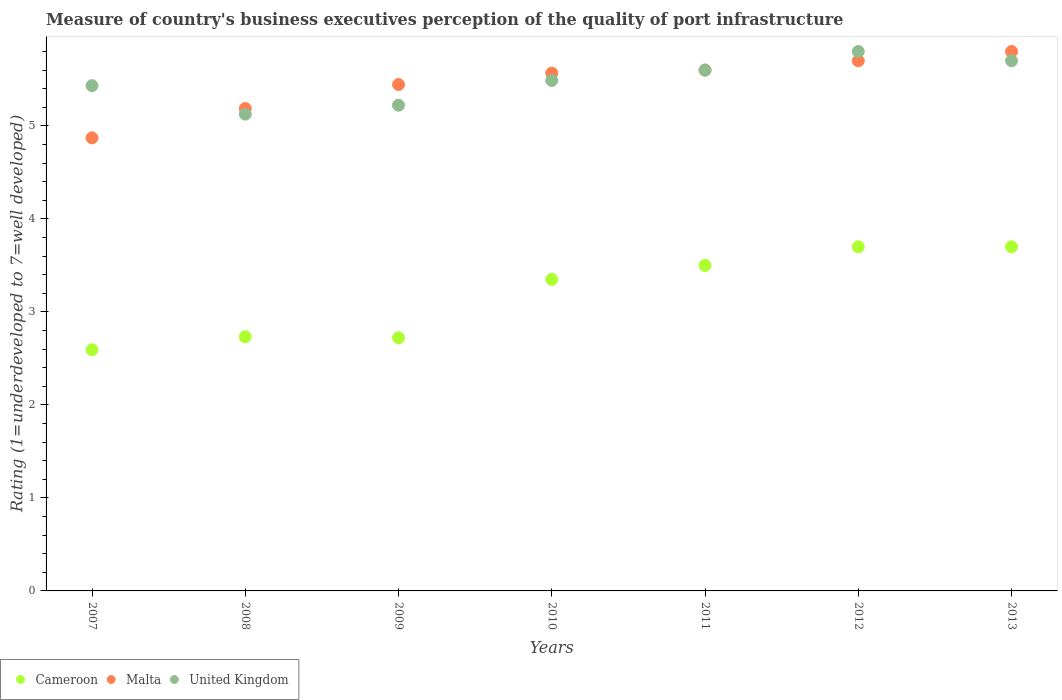Is the number of dotlines equal to the number of legend labels?
Your answer should be very brief. Yes. What is the ratings of the quality of port infrastructure in United Kingdom in 2010?
Offer a very short reply. 5.49. Across all years, what is the maximum ratings of the quality of port infrastructure in Malta?
Offer a terse response. 5.8. Across all years, what is the minimum ratings of the quality of port infrastructure in Cameroon?
Provide a short and direct response. 2.59. In which year was the ratings of the quality of port infrastructure in Malta maximum?
Your response must be concise. 2013. In which year was the ratings of the quality of port infrastructure in United Kingdom minimum?
Give a very brief answer. 2008. What is the total ratings of the quality of port infrastructure in United Kingdom in the graph?
Ensure brevity in your answer.  38.37. What is the difference between the ratings of the quality of port infrastructure in Malta in 2008 and that in 2009?
Provide a succinct answer. -0.26. What is the difference between the ratings of the quality of port infrastructure in Cameroon in 2007 and the ratings of the quality of port infrastructure in United Kingdom in 2012?
Your response must be concise. -3.21. What is the average ratings of the quality of port infrastructure in Malta per year?
Keep it short and to the point. 5.45. In the year 2009, what is the difference between the ratings of the quality of port infrastructure in Malta and ratings of the quality of port infrastructure in United Kingdom?
Make the answer very short. 0.22. What is the ratio of the ratings of the quality of port infrastructure in Malta in 2012 to that in 2013?
Make the answer very short. 0.98. Is the difference between the ratings of the quality of port infrastructure in Malta in 2007 and 2012 greater than the difference between the ratings of the quality of port infrastructure in United Kingdom in 2007 and 2012?
Make the answer very short. No. What is the difference between the highest and the second highest ratings of the quality of port infrastructure in Cameroon?
Offer a very short reply. 0. What is the difference between the highest and the lowest ratings of the quality of port infrastructure in United Kingdom?
Your response must be concise. 0.67. Is the sum of the ratings of the quality of port infrastructure in Cameroon in 2009 and 2010 greater than the maximum ratings of the quality of port infrastructure in United Kingdom across all years?
Offer a very short reply. Yes. Is it the case that in every year, the sum of the ratings of the quality of port infrastructure in Malta and ratings of the quality of port infrastructure in United Kingdom  is greater than the ratings of the quality of port infrastructure in Cameroon?
Your answer should be very brief. Yes. Is the ratings of the quality of port infrastructure in Cameroon strictly less than the ratings of the quality of port infrastructure in Malta over the years?
Make the answer very short. Yes. How many dotlines are there?
Make the answer very short. 3. How many years are there in the graph?
Make the answer very short. 7. What is the difference between two consecutive major ticks on the Y-axis?
Offer a very short reply. 1. Are the values on the major ticks of Y-axis written in scientific E-notation?
Offer a terse response. No. Does the graph contain grids?
Offer a very short reply. No. How many legend labels are there?
Keep it short and to the point. 3. How are the legend labels stacked?
Provide a succinct answer. Horizontal. What is the title of the graph?
Provide a short and direct response. Measure of country's business executives perception of the quality of port infrastructure. Does "Bosnia and Herzegovina" appear as one of the legend labels in the graph?
Offer a very short reply. No. What is the label or title of the X-axis?
Your answer should be compact. Years. What is the label or title of the Y-axis?
Keep it short and to the point. Rating (1=underdeveloped to 7=well developed). What is the Rating (1=underdeveloped to 7=well developed) of Cameroon in 2007?
Offer a terse response. 2.59. What is the Rating (1=underdeveloped to 7=well developed) in Malta in 2007?
Ensure brevity in your answer.  4.87. What is the Rating (1=underdeveloped to 7=well developed) in United Kingdom in 2007?
Keep it short and to the point. 5.43. What is the Rating (1=underdeveloped to 7=well developed) in Cameroon in 2008?
Provide a succinct answer. 2.73. What is the Rating (1=underdeveloped to 7=well developed) in Malta in 2008?
Provide a short and direct response. 5.19. What is the Rating (1=underdeveloped to 7=well developed) of United Kingdom in 2008?
Keep it short and to the point. 5.13. What is the Rating (1=underdeveloped to 7=well developed) in Cameroon in 2009?
Keep it short and to the point. 2.72. What is the Rating (1=underdeveloped to 7=well developed) of Malta in 2009?
Offer a terse response. 5.44. What is the Rating (1=underdeveloped to 7=well developed) of United Kingdom in 2009?
Provide a succinct answer. 5.22. What is the Rating (1=underdeveloped to 7=well developed) of Cameroon in 2010?
Offer a terse response. 3.35. What is the Rating (1=underdeveloped to 7=well developed) of Malta in 2010?
Make the answer very short. 5.57. What is the Rating (1=underdeveloped to 7=well developed) of United Kingdom in 2010?
Offer a terse response. 5.49. What is the Rating (1=underdeveloped to 7=well developed) of Malta in 2011?
Your answer should be very brief. 5.6. What is the Rating (1=underdeveloped to 7=well developed) of United Kingdom in 2011?
Offer a very short reply. 5.6. What is the Rating (1=underdeveloped to 7=well developed) in Malta in 2012?
Your response must be concise. 5.7. What is the Rating (1=underdeveloped to 7=well developed) in United Kingdom in 2012?
Make the answer very short. 5.8. Across all years, what is the maximum Rating (1=underdeveloped to 7=well developed) of United Kingdom?
Your response must be concise. 5.8. Across all years, what is the minimum Rating (1=underdeveloped to 7=well developed) in Cameroon?
Provide a succinct answer. 2.59. Across all years, what is the minimum Rating (1=underdeveloped to 7=well developed) of Malta?
Make the answer very short. 4.87. Across all years, what is the minimum Rating (1=underdeveloped to 7=well developed) in United Kingdom?
Provide a short and direct response. 5.13. What is the total Rating (1=underdeveloped to 7=well developed) of Cameroon in the graph?
Provide a succinct answer. 22.3. What is the total Rating (1=underdeveloped to 7=well developed) in Malta in the graph?
Your answer should be compact. 38.17. What is the total Rating (1=underdeveloped to 7=well developed) in United Kingdom in the graph?
Offer a terse response. 38.37. What is the difference between the Rating (1=underdeveloped to 7=well developed) of Cameroon in 2007 and that in 2008?
Your answer should be compact. -0.14. What is the difference between the Rating (1=underdeveloped to 7=well developed) of Malta in 2007 and that in 2008?
Provide a short and direct response. -0.32. What is the difference between the Rating (1=underdeveloped to 7=well developed) of United Kingdom in 2007 and that in 2008?
Give a very brief answer. 0.31. What is the difference between the Rating (1=underdeveloped to 7=well developed) in Cameroon in 2007 and that in 2009?
Your answer should be compact. -0.13. What is the difference between the Rating (1=underdeveloped to 7=well developed) in Malta in 2007 and that in 2009?
Offer a terse response. -0.57. What is the difference between the Rating (1=underdeveloped to 7=well developed) in United Kingdom in 2007 and that in 2009?
Provide a succinct answer. 0.21. What is the difference between the Rating (1=underdeveloped to 7=well developed) in Cameroon in 2007 and that in 2010?
Offer a very short reply. -0.76. What is the difference between the Rating (1=underdeveloped to 7=well developed) in Malta in 2007 and that in 2010?
Ensure brevity in your answer.  -0.7. What is the difference between the Rating (1=underdeveloped to 7=well developed) of United Kingdom in 2007 and that in 2010?
Make the answer very short. -0.06. What is the difference between the Rating (1=underdeveloped to 7=well developed) in Cameroon in 2007 and that in 2011?
Provide a short and direct response. -0.91. What is the difference between the Rating (1=underdeveloped to 7=well developed) in Malta in 2007 and that in 2011?
Provide a succinct answer. -0.73. What is the difference between the Rating (1=underdeveloped to 7=well developed) in United Kingdom in 2007 and that in 2011?
Offer a terse response. -0.17. What is the difference between the Rating (1=underdeveloped to 7=well developed) in Cameroon in 2007 and that in 2012?
Your answer should be very brief. -1.11. What is the difference between the Rating (1=underdeveloped to 7=well developed) in Malta in 2007 and that in 2012?
Offer a terse response. -0.83. What is the difference between the Rating (1=underdeveloped to 7=well developed) in United Kingdom in 2007 and that in 2012?
Your answer should be compact. -0.37. What is the difference between the Rating (1=underdeveloped to 7=well developed) in Cameroon in 2007 and that in 2013?
Your answer should be compact. -1.11. What is the difference between the Rating (1=underdeveloped to 7=well developed) in Malta in 2007 and that in 2013?
Keep it short and to the point. -0.93. What is the difference between the Rating (1=underdeveloped to 7=well developed) in United Kingdom in 2007 and that in 2013?
Keep it short and to the point. -0.27. What is the difference between the Rating (1=underdeveloped to 7=well developed) in Cameroon in 2008 and that in 2009?
Make the answer very short. 0.01. What is the difference between the Rating (1=underdeveloped to 7=well developed) of Malta in 2008 and that in 2009?
Offer a terse response. -0.26. What is the difference between the Rating (1=underdeveloped to 7=well developed) in United Kingdom in 2008 and that in 2009?
Keep it short and to the point. -0.1. What is the difference between the Rating (1=underdeveloped to 7=well developed) of Cameroon in 2008 and that in 2010?
Offer a very short reply. -0.62. What is the difference between the Rating (1=underdeveloped to 7=well developed) of Malta in 2008 and that in 2010?
Ensure brevity in your answer.  -0.38. What is the difference between the Rating (1=underdeveloped to 7=well developed) in United Kingdom in 2008 and that in 2010?
Your response must be concise. -0.36. What is the difference between the Rating (1=underdeveloped to 7=well developed) of Cameroon in 2008 and that in 2011?
Provide a short and direct response. -0.77. What is the difference between the Rating (1=underdeveloped to 7=well developed) in Malta in 2008 and that in 2011?
Your response must be concise. -0.41. What is the difference between the Rating (1=underdeveloped to 7=well developed) in United Kingdom in 2008 and that in 2011?
Offer a very short reply. -0.47. What is the difference between the Rating (1=underdeveloped to 7=well developed) of Cameroon in 2008 and that in 2012?
Give a very brief answer. -0.97. What is the difference between the Rating (1=underdeveloped to 7=well developed) of Malta in 2008 and that in 2012?
Offer a very short reply. -0.51. What is the difference between the Rating (1=underdeveloped to 7=well developed) in United Kingdom in 2008 and that in 2012?
Offer a very short reply. -0.67. What is the difference between the Rating (1=underdeveloped to 7=well developed) in Cameroon in 2008 and that in 2013?
Offer a terse response. -0.97. What is the difference between the Rating (1=underdeveloped to 7=well developed) in Malta in 2008 and that in 2013?
Offer a very short reply. -0.61. What is the difference between the Rating (1=underdeveloped to 7=well developed) of United Kingdom in 2008 and that in 2013?
Your answer should be compact. -0.57. What is the difference between the Rating (1=underdeveloped to 7=well developed) of Cameroon in 2009 and that in 2010?
Your answer should be compact. -0.63. What is the difference between the Rating (1=underdeveloped to 7=well developed) of Malta in 2009 and that in 2010?
Provide a succinct answer. -0.12. What is the difference between the Rating (1=underdeveloped to 7=well developed) in United Kingdom in 2009 and that in 2010?
Offer a terse response. -0.27. What is the difference between the Rating (1=underdeveloped to 7=well developed) in Cameroon in 2009 and that in 2011?
Your response must be concise. -0.78. What is the difference between the Rating (1=underdeveloped to 7=well developed) of Malta in 2009 and that in 2011?
Give a very brief answer. -0.15. What is the difference between the Rating (1=underdeveloped to 7=well developed) of United Kingdom in 2009 and that in 2011?
Your answer should be compact. -0.38. What is the difference between the Rating (1=underdeveloped to 7=well developed) in Cameroon in 2009 and that in 2012?
Offer a very short reply. -0.98. What is the difference between the Rating (1=underdeveloped to 7=well developed) of Malta in 2009 and that in 2012?
Offer a terse response. -0.26. What is the difference between the Rating (1=underdeveloped to 7=well developed) in United Kingdom in 2009 and that in 2012?
Provide a short and direct response. -0.58. What is the difference between the Rating (1=underdeveloped to 7=well developed) of Cameroon in 2009 and that in 2013?
Your answer should be compact. -0.98. What is the difference between the Rating (1=underdeveloped to 7=well developed) in Malta in 2009 and that in 2013?
Make the answer very short. -0.35. What is the difference between the Rating (1=underdeveloped to 7=well developed) of United Kingdom in 2009 and that in 2013?
Offer a very short reply. -0.48. What is the difference between the Rating (1=underdeveloped to 7=well developed) of Cameroon in 2010 and that in 2011?
Offer a very short reply. -0.15. What is the difference between the Rating (1=underdeveloped to 7=well developed) in Malta in 2010 and that in 2011?
Provide a short and direct response. -0.03. What is the difference between the Rating (1=underdeveloped to 7=well developed) in United Kingdom in 2010 and that in 2011?
Your answer should be compact. -0.11. What is the difference between the Rating (1=underdeveloped to 7=well developed) in Cameroon in 2010 and that in 2012?
Your answer should be compact. -0.35. What is the difference between the Rating (1=underdeveloped to 7=well developed) of Malta in 2010 and that in 2012?
Keep it short and to the point. -0.13. What is the difference between the Rating (1=underdeveloped to 7=well developed) in United Kingdom in 2010 and that in 2012?
Make the answer very short. -0.31. What is the difference between the Rating (1=underdeveloped to 7=well developed) of Cameroon in 2010 and that in 2013?
Provide a short and direct response. -0.35. What is the difference between the Rating (1=underdeveloped to 7=well developed) in Malta in 2010 and that in 2013?
Offer a very short reply. -0.23. What is the difference between the Rating (1=underdeveloped to 7=well developed) of United Kingdom in 2010 and that in 2013?
Keep it short and to the point. -0.21. What is the difference between the Rating (1=underdeveloped to 7=well developed) of Cameroon in 2011 and that in 2013?
Offer a terse response. -0.2. What is the difference between the Rating (1=underdeveloped to 7=well developed) in Malta in 2011 and that in 2013?
Your answer should be very brief. -0.2. What is the difference between the Rating (1=underdeveloped to 7=well developed) of United Kingdom in 2011 and that in 2013?
Provide a succinct answer. -0.1. What is the difference between the Rating (1=underdeveloped to 7=well developed) of Cameroon in 2012 and that in 2013?
Your response must be concise. 0. What is the difference between the Rating (1=underdeveloped to 7=well developed) in Malta in 2012 and that in 2013?
Provide a succinct answer. -0.1. What is the difference between the Rating (1=underdeveloped to 7=well developed) in Cameroon in 2007 and the Rating (1=underdeveloped to 7=well developed) in Malta in 2008?
Your response must be concise. -2.59. What is the difference between the Rating (1=underdeveloped to 7=well developed) in Cameroon in 2007 and the Rating (1=underdeveloped to 7=well developed) in United Kingdom in 2008?
Provide a short and direct response. -2.53. What is the difference between the Rating (1=underdeveloped to 7=well developed) in Malta in 2007 and the Rating (1=underdeveloped to 7=well developed) in United Kingdom in 2008?
Your answer should be compact. -0.25. What is the difference between the Rating (1=underdeveloped to 7=well developed) in Cameroon in 2007 and the Rating (1=underdeveloped to 7=well developed) in Malta in 2009?
Make the answer very short. -2.85. What is the difference between the Rating (1=underdeveloped to 7=well developed) of Cameroon in 2007 and the Rating (1=underdeveloped to 7=well developed) of United Kingdom in 2009?
Your response must be concise. -2.63. What is the difference between the Rating (1=underdeveloped to 7=well developed) in Malta in 2007 and the Rating (1=underdeveloped to 7=well developed) in United Kingdom in 2009?
Offer a very short reply. -0.35. What is the difference between the Rating (1=underdeveloped to 7=well developed) in Cameroon in 2007 and the Rating (1=underdeveloped to 7=well developed) in Malta in 2010?
Make the answer very short. -2.97. What is the difference between the Rating (1=underdeveloped to 7=well developed) in Cameroon in 2007 and the Rating (1=underdeveloped to 7=well developed) in United Kingdom in 2010?
Offer a terse response. -2.9. What is the difference between the Rating (1=underdeveloped to 7=well developed) of Malta in 2007 and the Rating (1=underdeveloped to 7=well developed) of United Kingdom in 2010?
Your answer should be compact. -0.62. What is the difference between the Rating (1=underdeveloped to 7=well developed) in Cameroon in 2007 and the Rating (1=underdeveloped to 7=well developed) in Malta in 2011?
Ensure brevity in your answer.  -3.01. What is the difference between the Rating (1=underdeveloped to 7=well developed) in Cameroon in 2007 and the Rating (1=underdeveloped to 7=well developed) in United Kingdom in 2011?
Give a very brief answer. -3.01. What is the difference between the Rating (1=underdeveloped to 7=well developed) in Malta in 2007 and the Rating (1=underdeveloped to 7=well developed) in United Kingdom in 2011?
Your answer should be very brief. -0.73. What is the difference between the Rating (1=underdeveloped to 7=well developed) in Cameroon in 2007 and the Rating (1=underdeveloped to 7=well developed) in Malta in 2012?
Keep it short and to the point. -3.11. What is the difference between the Rating (1=underdeveloped to 7=well developed) of Cameroon in 2007 and the Rating (1=underdeveloped to 7=well developed) of United Kingdom in 2012?
Your answer should be very brief. -3.21. What is the difference between the Rating (1=underdeveloped to 7=well developed) of Malta in 2007 and the Rating (1=underdeveloped to 7=well developed) of United Kingdom in 2012?
Provide a succinct answer. -0.93. What is the difference between the Rating (1=underdeveloped to 7=well developed) in Cameroon in 2007 and the Rating (1=underdeveloped to 7=well developed) in Malta in 2013?
Offer a very short reply. -3.21. What is the difference between the Rating (1=underdeveloped to 7=well developed) in Cameroon in 2007 and the Rating (1=underdeveloped to 7=well developed) in United Kingdom in 2013?
Keep it short and to the point. -3.11. What is the difference between the Rating (1=underdeveloped to 7=well developed) of Malta in 2007 and the Rating (1=underdeveloped to 7=well developed) of United Kingdom in 2013?
Your answer should be very brief. -0.83. What is the difference between the Rating (1=underdeveloped to 7=well developed) in Cameroon in 2008 and the Rating (1=underdeveloped to 7=well developed) in Malta in 2009?
Offer a very short reply. -2.71. What is the difference between the Rating (1=underdeveloped to 7=well developed) of Cameroon in 2008 and the Rating (1=underdeveloped to 7=well developed) of United Kingdom in 2009?
Your answer should be compact. -2.49. What is the difference between the Rating (1=underdeveloped to 7=well developed) in Malta in 2008 and the Rating (1=underdeveloped to 7=well developed) in United Kingdom in 2009?
Ensure brevity in your answer.  -0.04. What is the difference between the Rating (1=underdeveloped to 7=well developed) in Cameroon in 2008 and the Rating (1=underdeveloped to 7=well developed) in Malta in 2010?
Give a very brief answer. -2.84. What is the difference between the Rating (1=underdeveloped to 7=well developed) of Cameroon in 2008 and the Rating (1=underdeveloped to 7=well developed) of United Kingdom in 2010?
Your answer should be compact. -2.76. What is the difference between the Rating (1=underdeveloped to 7=well developed) in Malta in 2008 and the Rating (1=underdeveloped to 7=well developed) in United Kingdom in 2010?
Give a very brief answer. -0.3. What is the difference between the Rating (1=underdeveloped to 7=well developed) of Cameroon in 2008 and the Rating (1=underdeveloped to 7=well developed) of Malta in 2011?
Your response must be concise. -2.87. What is the difference between the Rating (1=underdeveloped to 7=well developed) in Cameroon in 2008 and the Rating (1=underdeveloped to 7=well developed) in United Kingdom in 2011?
Your response must be concise. -2.87. What is the difference between the Rating (1=underdeveloped to 7=well developed) in Malta in 2008 and the Rating (1=underdeveloped to 7=well developed) in United Kingdom in 2011?
Your answer should be compact. -0.41. What is the difference between the Rating (1=underdeveloped to 7=well developed) in Cameroon in 2008 and the Rating (1=underdeveloped to 7=well developed) in Malta in 2012?
Keep it short and to the point. -2.97. What is the difference between the Rating (1=underdeveloped to 7=well developed) of Cameroon in 2008 and the Rating (1=underdeveloped to 7=well developed) of United Kingdom in 2012?
Ensure brevity in your answer.  -3.07. What is the difference between the Rating (1=underdeveloped to 7=well developed) in Malta in 2008 and the Rating (1=underdeveloped to 7=well developed) in United Kingdom in 2012?
Ensure brevity in your answer.  -0.61. What is the difference between the Rating (1=underdeveloped to 7=well developed) of Cameroon in 2008 and the Rating (1=underdeveloped to 7=well developed) of Malta in 2013?
Ensure brevity in your answer.  -3.07. What is the difference between the Rating (1=underdeveloped to 7=well developed) in Cameroon in 2008 and the Rating (1=underdeveloped to 7=well developed) in United Kingdom in 2013?
Give a very brief answer. -2.97. What is the difference between the Rating (1=underdeveloped to 7=well developed) in Malta in 2008 and the Rating (1=underdeveloped to 7=well developed) in United Kingdom in 2013?
Keep it short and to the point. -0.51. What is the difference between the Rating (1=underdeveloped to 7=well developed) of Cameroon in 2009 and the Rating (1=underdeveloped to 7=well developed) of Malta in 2010?
Keep it short and to the point. -2.85. What is the difference between the Rating (1=underdeveloped to 7=well developed) in Cameroon in 2009 and the Rating (1=underdeveloped to 7=well developed) in United Kingdom in 2010?
Give a very brief answer. -2.77. What is the difference between the Rating (1=underdeveloped to 7=well developed) in Malta in 2009 and the Rating (1=underdeveloped to 7=well developed) in United Kingdom in 2010?
Offer a very short reply. -0.04. What is the difference between the Rating (1=underdeveloped to 7=well developed) of Cameroon in 2009 and the Rating (1=underdeveloped to 7=well developed) of Malta in 2011?
Your answer should be compact. -2.88. What is the difference between the Rating (1=underdeveloped to 7=well developed) in Cameroon in 2009 and the Rating (1=underdeveloped to 7=well developed) in United Kingdom in 2011?
Offer a very short reply. -2.88. What is the difference between the Rating (1=underdeveloped to 7=well developed) of Malta in 2009 and the Rating (1=underdeveloped to 7=well developed) of United Kingdom in 2011?
Provide a short and direct response. -0.15. What is the difference between the Rating (1=underdeveloped to 7=well developed) in Cameroon in 2009 and the Rating (1=underdeveloped to 7=well developed) in Malta in 2012?
Your response must be concise. -2.98. What is the difference between the Rating (1=underdeveloped to 7=well developed) of Cameroon in 2009 and the Rating (1=underdeveloped to 7=well developed) of United Kingdom in 2012?
Keep it short and to the point. -3.08. What is the difference between the Rating (1=underdeveloped to 7=well developed) of Malta in 2009 and the Rating (1=underdeveloped to 7=well developed) of United Kingdom in 2012?
Give a very brief answer. -0.35. What is the difference between the Rating (1=underdeveloped to 7=well developed) in Cameroon in 2009 and the Rating (1=underdeveloped to 7=well developed) in Malta in 2013?
Your answer should be very brief. -3.08. What is the difference between the Rating (1=underdeveloped to 7=well developed) of Cameroon in 2009 and the Rating (1=underdeveloped to 7=well developed) of United Kingdom in 2013?
Make the answer very short. -2.98. What is the difference between the Rating (1=underdeveloped to 7=well developed) in Malta in 2009 and the Rating (1=underdeveloped to 7=well developed) in United Kingdom in 2013?
Keep it short and to the point. -0.26. What is the difference between the Rating (1=underdeveloped to 7=well developed) in Cameroon in 2010 and the Rating (1=underdeveloped to 7=well developed) in Malta in 2011?
Ensure brevity in your answer.  -2.25. What is the difference between the Rating (1=underdeveloped to 7=well developed) of Cameroon in 2010 and the Rating (1=underdeveloped to 7=well developed) of United Kingdom in 2011?
Keep it short and to the point. -2.25. What is the difference between the Rating (1=underdeveloped to 7=well developed) of Malta in 2010 and the Rating (1=underdeveloped to 7=well developed) of United Kingdom in 2011?
Provide a short and direct response. -0.03. What is the difference between the Rating (1=underdeveloped to 7=well developed) in Cameroon in 2010 and the Rating (1=underdeveloped to 7=well developed) in Malta in 2012?
Make the answer very short. -2.35. What is the difference between the Rating (1=underdeveloped to 7=well developed) of Cameroon in 2010 and the Rating (1=underdeveloped to 7=well developed) of United Kingdom in 2012?
Your response must be concise. -2.45. What is the difference between the Rating (1=underdeveloped to 7=well developed) of Malta in 2010 and the Rating (1=underdeveloped to 7=well developed) of United Kingdom in 2012?
Your answer should be compact. -0.23. What is the difference between the Rating (1=underdeveloped to 7=well developed) of Cameroon in 2010 and the Rating (1=underdeveloped to 7=well developed) of Malta in 2013?
Your answer should be compact. -2.45. What is the difference between the Rating (1=underdeveloped to 7=well developed) of Cameroon in 2010 and the Rating (1=underdeveloped to 7=well developed) of United Kingdom in 2013?
Ensure brevity in your answer.  -2.35. What is the difference between the Rating (1=underdeveloped to 7=well developed) of Malta in 2010 and the Rating (1=underdeveloped to 7=well developed) of United Kingdom in 2013?
Provide a succinct answer. -0.13. What is the difference between the Rating (1=underdeveloped to 7=well developed) of Cameroon in 2011 and the Rating (1=underdeveloped to 7=well developed) of United Kingdom in 2012?
Provide a short and direct response. -2.3. What is the difference between the Rating (1=underdeveloped to 7=well developed) of Cameroon in 2011 and the Rating (1=underdeveloped to 7=well developed) of Malta in 2013?
Make the answer very short. -2.3. What is the difference between the Rating (1=underdeveloped to 7=well developed) of Cameroon in 2011 and the Rating (1=underdeveloped to 7=well developed) of United Kingdom in 2013?
Make the answer very short. -2.2. What is the difference between the Rating (1=underdeveloped to 7=well developed) of Malta in 2011 and the Rating (1=underdeveloped to 7=well developed) of United Kingdom in 2013?
Provide a succinct answer. -0.1. What is the difference between the Rating (1=underdeveloped to 7=well developed) of Cameroon in 2012 and the Rating (1=underdeveloped to 7=well developed) of Malta in 2013?
Offer a very short reply. -2.1. What is the difference between the Rating (1=underdeveloped to 7=well developed) in Malta in 2012 and the Rating (1=underdeveloped to 7=well developed) in United Kingdom in 2013?
Provide a succinct answer. 0. What is the average Rating (1=underdeveloped to 7=well developed) of Cameroon per year?
Your answer should be compact. 3.19. What is the average Rating (1=underdeveloped to 7=well developed) in Malta per year?
Offer a very short reply. 5.45. What is the average Rating (1=underdeveloped to 7=well developed) of United Kingdom per year?
Your response must be concise. 5.48. In the year 2007, what is the difference between the Rating (1=underdeveloped to 7=well developed) in Cameroon and Rating (1=underdeveloped to 7=well developed) in Malta?
Your answer should be compact. -2.28. In the year 2007, what is the difference between the Rating (1=underdeveloped to 7=well developed) of Cameroon and Rating (1=underdeveloped to 7=well developed) of United Kingdom?
Offer a terse response. -2.84. In the year 2007, what is the difference between the Rating (1=underdeveloped to 7=well developed) in Malta and Rating (1=underdeveloped to 7=well developed) in United Kingdom?
Offer a terse response. -0.56. In the year 2008, what is the difference between the Rating (1=underdeveloped to 7=well developed) in Cameroon and Rating (1=underdeveloped to 7=well developed) in Malta?
Your answer should be compact. -2.45. In the year 2008, what is the difference between the Rating (1=underdeveloped to 7=well developed) in Cameroon and Rating (1=underdeveloped to 7=well developed) in United Kingdom?
Give a very brief answer. -2.39. In the year 2008, what is the difference between the Rating (1=underdeveloped to 7=well developed) in Malta and Rating (1=underdeveloped to 7=well developed) in United Kingdom?
Ensure brevity in your answer.  0.06. In the year 2009, what is the difference between the Rating (1=underdeveloped to 7=well developed) of Cameroon and Rating (1=underdeveloped to 7=well developed) of Malta?
Provide a short and direct response. -2.72. In the year 2009, what is the difference between the Rating (1=underdeveloped to 7=well developed) of Cameroon and Rating (1=underdeveloped to 7=well developed) of United Kingdom?
Your answer should be very brief. -2.5. In the year 2009, what is the difference between the Rating (1=underdeveloped to 7=well developed) of Malta and Rating (1=underdeveloped to 7=well developed) of United Kingdom?
Provide a succinct answer. 0.22. In the year 2010, what is the difference between the Rating (1=underdeveloped to 7=well developed) in Cameroon and Rating (1=underdeveloped to 7=well developed) in Malta?
Your response must be concise. -2.22. In the year 2010, what is the difference between the Rating (1=underdeveloped to 7=well developed) in Cameroon and Rating (1=underdeveloped to 7=well developed) in United Kingdom?
Keep it short and to the point. -2.14. In the year 2010, what is the difference between the Rating (1=underdeveloped to 7=well developed) in Malta and Rating (1=underdeveloped to 7=well developed) in United Kingdom?
Offer a terse response. 0.08. In the year 2011, what is the difference between the Rating (1=underdeveloped to 7=well developed) in Cameroon and Rating (1=underdeveloped to 7=well developed) in Malta?
Ensure brevity in your answer.  -2.1. In the year 2012, what is the difference between the Rating (1=underdeveloped to 7=well developed) of Cameroon and Rating (1=underdeveloped to 7=well developed) of Malta?
Your answer should be very brief. -2. In the year 2012, what is the difference between the Rating (1=underdeveloped to 7=well developed) of Malta and Rating (1=underdeveloped to 7=well developed) of United Kingdom?
Your response must be concise. -0.1. In the year 2013, what is the difference between the Rating (1=underdeveloped to 7=well developed) of Malta and Rating (1=underdeveloped to 7=well developed) of United Kingdom?
Offer a terse response. 0.1. What is the ratio of the Rating (1=underdeveloped to 7=well developed) in Cameroon in 2007 to that in 2008?
Your answer should be very brief. 0.95. What is the ratio of the Rating (1=underdeveloped to 7=well developed) of Malta in 2007 to that in 2008?
Offer a very short reply. 0.94. What is the ratio of the Rating (1=underdeveloped to 7=well developed) of United Kingdom in 2007 to that in 2008?
Give a very brief answer. 1.06. What is the ratio of the Rating (1=underdeveloped to 7=well developed) of Cameroon in 2007 to that in 2009?
Ensure brevity in your answer.  0.95. What is the ratio of the Rating (1=underdeveloped to 7=well developed) of Malta in 2007 to that in 2009?
Keep it short and to the point. 0.89. What is the ratio of the Rating (1=underdeveloped to 7=well developed) in United Kingdom in 2007 to that in 2009?
Give a very brief answer. 1.04. What is the ratio of the Rating (1=underdeveloped to 7=well developed) of Cameroon in 2007 to that in 2010?
Keep it short and to the point. 0.77. What is the ratio of the Rating (1=underdeveloped to 7=well developed) of Malta in 2007 to that in 2010?
Provide a short and direct response. 0.88. What is the ratio of the Rating (1=underdeveloped to 7=well developed) of Cameroon in 2007 to that in 2011?
Offer a terse response. 0.74. What is the ratio of the Rating (1=underdeveloped to 7=well developed) in Malta in 2007 to that in 2011?
Keep it short and to the point. 0.87. What is the ratio of the Rating (1=underdeveloped to 7=well developed) in United Kingdom in 2007 to that in 2011?
Ensure brevity in your answer.  0.97. What is the ratio of the Rating (1=underdeveloped to 7=well developed) of Cameroon in 2007 to that in 2012?
Provide a succinct answer. 0.7. What is the ratio of the Rating (1=underdeveloped to 7=well developed) in Malta in 2007 to that in 2012?
Offer a terse response. 0.85. What is the ratio of the Rating (1=underdeveloped to 7=well developed) in United Kingdom in 2007 to that in 2012?
Ensure brevity in your answer.  0.94. What is the ratio of the Rating (1=underdeveloped to 7=well developed) of Cameroon in 2007 to that in 2013?
Ensure brevity in your answer.  0.7. What is the ratio of the Rating (1=underdeveloped to 7=well developed) of Malta in 2007 to that in 2013?
Offer a terse response. 0.84. What is the ratio of the Rating (1=underdeveloped to 7=well developed) of United Kingdom in 2007 to that in 2013?
Keep it short and to the point. 0.95. What is the ratio of the Rating (1=underdeveloped to 7=well developed) in Cameroon in 2008 to that in 2009?
Provide a succinct answer. 1. What is the ratio of the Rating (1=underdeveloped to 7=well developed) in Malta in 2008 to that in 2009?
Ensure brevity in your answer.  0.95. What is the ratio of the Rating (1=underdeveloped to 7=well developed) of United Kingdom in 2008 to that in 2009?
Offer a terse response. 0.98. What is the ratio of the Rating (1=underdeveloped to 7=well developed) in Cameroon in 2008 to that in 2010?
Keep it short and to the point. 0.82. What is the ratio of the Rating (1=underdeveloped to 7=well developed) in Malta in 2008 to that in 2010?
Ensure brevity in your answer.  0.93. What is the ratio of the Rating (1=underdeveloped to 7=well developed) of United Kingdom in 2008 to that in 2010?
Provide a succinct answer. 0.93. What is the ratio of the Rating (1=underdeveloped to 7=well developed) in Cameroon in 2008 to that in 2011?
Provide a short and direct response. 0.78. What is the ratio of the Rating (1=underdeveloped to 7=well developed) in Malta in 2008 to that in 2011?
Make the answer very short. 0.93. What is the ratio of the Rating (1=underdeveloped to 7=well developed) in United Kingdom in 2008 to that in 2011?
Your answer should be very brief. 0.92. What is the ratio of the Rating (1=underdeveloped to 7=well developed) in Cameroon in 2008 to that in 2012?
Provide a succinct answer. 0.74. What is the ratio of the Rating (1=underdeveloped to 7=well developed) in Malta in 2008 to that in 2012?
Offer a terse response. 0.91. What is the ratio of the Rating (1=underdeveloped to 7=well developed) of United Kingdom in 2008 to that in 2012?
Give a very brief answer. 0.88. What is the ratio of the Rating (1=underdeveloped to 7=well developed) in Cameroon in 2008 to that in 2013?
Provide a succinct answer. 0.74. What is the ratio of the Rating (1=underdeveloped to 7=well developed) in Malta in 2008 to that in 2013?
Give a very brief answer. 0.89. What is the ratio of the Rating (1=underdeveloped to 7=well developed) in United Kingdom in 2008 to that in 2013?
Provide a succinct answer. 0.9. What is the ratio of the Rating (1=underdeveloped to 7=well developed) of Cameroon in 2009 to that in 2010?
Your answer should be compact. 0.81. What is the ratio of the Rating (1=underdeveloped to 7=well developed) in United Kingdom in 2009 to that in 2010?
Keep it short and to the point. 0.95. What is the ratio of the Rating (1=underdeveloped to 7=well developed) in Cameroon in 2009 to that in 2011?
Offer a terse response. 0.78. What is the ratio of the Rating (1=underdeveloped to 7=well developed) in Malta in 2009 to that in 2011?
Offer a terse response. 0.97. What is the ratio of the Rating (1=underdeveloped to 7=well developed) of United Kingdom in 2009 to that in 2011?
Make the answer very short. 0.93. What is the ratio of the Rating (1=underdeveloped to 7=well developed) in Cameroon in 2009 to that in 2012?
Offer a very short reply. 0.74. What is the ratio of the Rating (1=underdeveloped to 7=well developed) of Malta in 2009 to that in 2012?
Your answer should be very brief. 0.96. What is the ratio of the Rating (1=underdeveloped to 7=well developed) in United Kingdom in 2009 to that in 2012?
Offer a terse response. 0.9. What is the ratio of the Rating (1=underdeveloped to 7=well developed) of Cameroon in 2009 to that in 2013?
Make the answer very short. 0.74. What is the ratio of the Rating (1=underdeveloped to 7=well developed) in Malta in 2009 to that in 2013?
Offer a terse response. 0.94. What is the ratio of the Rating (1=underdeveloped to 7=well developed) of United Kingdom in 2009 to that in 2013?
Ensure brevity in your answer.  0.92. What is the ratio of the Rating (1=underdeveloped to 7=well developed) of Cameroon in 2010 to that in 2011?
Provide a short and direct response. 0.96. What is the ratio of the Rating (1=underdeveloped to 7=well developed) of Malta in 2010 to that in 2011?
Provide a short and direct response. 0.99. What is the ratio of the Rating (1=underdeveloped to 7=well developed) of United Kingdom in 2010 to that in 2011?
Give a very brief answer. 0.98. What is the ratio of the Rating (1=underdeveloped to 7=well developed) of Cameroon in 2010 to that in 2012?
Offer a terse response. 0.91. What is the ratio of the Rating (1=underdeveloped to 7=well developed) of Malta in 2010 to that in 2012?
Your response must be concise. 0.98. What is the ratio of the Rating (1=underdeveloped to 7=well developed) of United Kingdom in 2010 to that in 2012?
Offer a terse response. 0.95. What is the ratio of the Rating (1=underdeveloped to 7=well developed) of Cameroon in 2010 to that in 2013?
Make the answer very short. 0.91. What is the ratio of the Rating (1=underdeveloped to 7=well developed) of Malta in 2010 to that in 2013?
Provide a succinct answer. 0.96. What is the ratio of the Rating (1=underdeveloped to 7=well developed) in United Kingdom in 2010 to that in 2013?
Your answer should be very brief. 0.96. What is the ratio of the Rating (1=underdeveloped to 7=well developed) in Cameroon in 2011 to that in 2012?
Keep it short and to the point. 0.95. What is the ratio of the Rating (1=underdeveloped to 7=well developed) of Malta in 2011 to that in 2012?
Offer a terse response. 0.98. What is the ratio of the Rating (1=underdeveloped to 7=well developed) in United Kingdom in 2011 to that in 2012?
Your answer should be very brief. 0.97. What is the ratio of the Rating (1=underdeveloped to 7=well developed) in Cameroon in 2011 to that in 2013?
Provide a succinct answer. 0.95. What is the ratio of the Rating (1=underdeveloped to 7=well developed) in Malta in 2011 to that in 2013?
Keep it short and to the point. 0.97. What is the ratio of the Rating (1=underdeveloped to 7=well developed) in United Kingdom in 2011 to that in 2013?
Your response must be concise. 0.98. What is the ratio of the Rating (1=underdeveloped to 7=well developed) in Malta in 2012 to that in 2013?
Your answer should be very brief. 0.98. What is the ratio of the Rating (1=underdeveloped to 7=well developed) of United Kingdom in 2012 to that in 2013?
Ensure brevity in your answer.  1.02. What is the difference between the highest and the second highest Rating (1=underdeveloped to 7=well developed) in Cameroon?
Provide a succinct answer. 0. What is the difference between the highest and the second highest Rating (1=underdeveloped to 7=well developed) in Malta?
Give a very brief answer. 0.1. What is the difference between the highest and the second highest Rating (1=underdeveloped to 7=well developed) in United Kingdom?
Offer a terse response. 0.1. What is the difference between the highest and the lowest Rating (1=underdeveloped to 7=well developed) in Cameroon?
Provide a succinct answer. 1.11. What is the difference between the highest and the lowest Rating (1=underdeveloped to 7=well developed) in Malta?
Offer a very short reply. 0.93. What is the difference between the highest and the lowest Rating (1=underdeveloped to 7=well developed) of United Kingdom?
Offer a terse response. 0.67. 